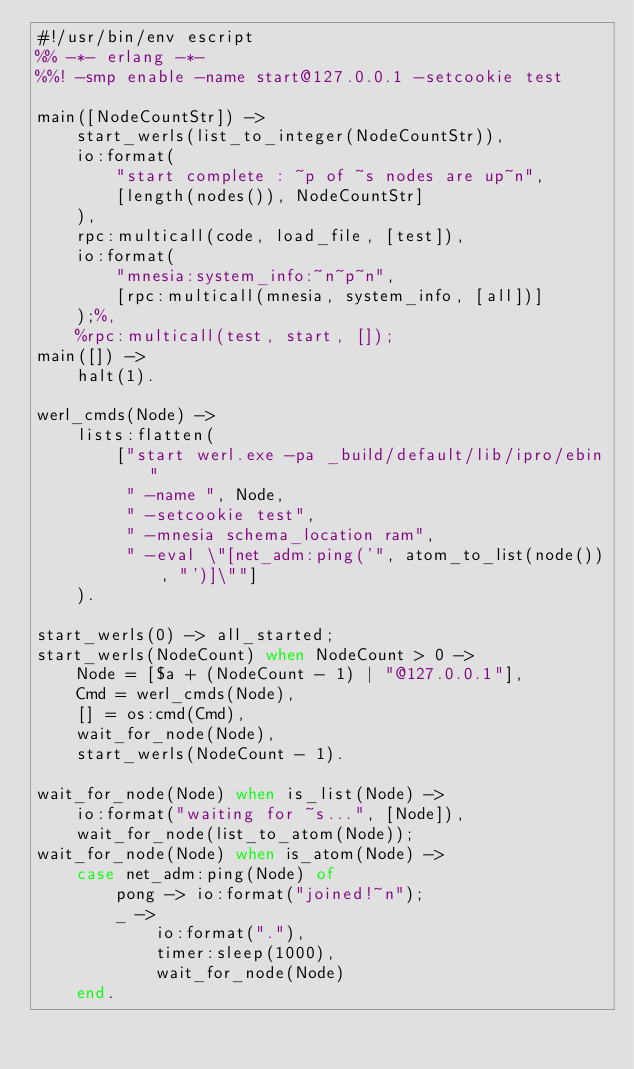<code> <loc_0><loc_0><loc_500><loc_500><_Erlang_>#!/usr/bin/env escript
%% -*- erlang -*-
%%! -smp enable -name start@127.0.0.1 -setcookie test

main([NodeCountStr]) ->
	start_werls(list_to_integer(NodeCountStr)),
	io:format(
		"start complete : ~p of ~s nodes are up~n",
		[length(nodes()), NodeCountStr]
	),
	rpc:multicall(code, load_file, [test]),
	io:format(
		"mnesia:system_info:~n~p~n",
	 	[rpc:multicall(mnesia, system_info, [all])]
	);%,
	%rpc:multicall(test, start, []);
main([]) ->
	halt(1).

werl_cmds(Node) ->
	lists:flatten(
		["start werl.exe -pa _build/default/lib/ipro/ebin"
		 " -name ", Node,
		 " -setcookie test",
		 " -mnesia schema_location ram",
		 " -eval \"[net_adm:ping('", atom_to_list(node()), "')]\""]
	).

start_werls(0) -> all_started;
start_werls(NodeCount) when NodeCount > 0 ->
	Node = [$a + (NodeCount - 1) | "@127.0.0.1"],
	Cmd = werl_cmds(Node),
	[] = os:cmd(Cmd),
	wait_for_node(Node),
	start_werls(NodeCount - 1).

wait_for_node(Node) when is_list(Node) ->
	io:format("waiting for ~s...", [Node]),
	wait_for_node(list_to_atom(Node));
wait_for_node(Node) when is_atom(Node) ->
	case net_adm:ping(Node) of
		pong -> io:format("joined!~n");
		_ ->
			io:format("."),
			timer:sleep(1000),
			wait_for_node(Node)
	end.</code> 